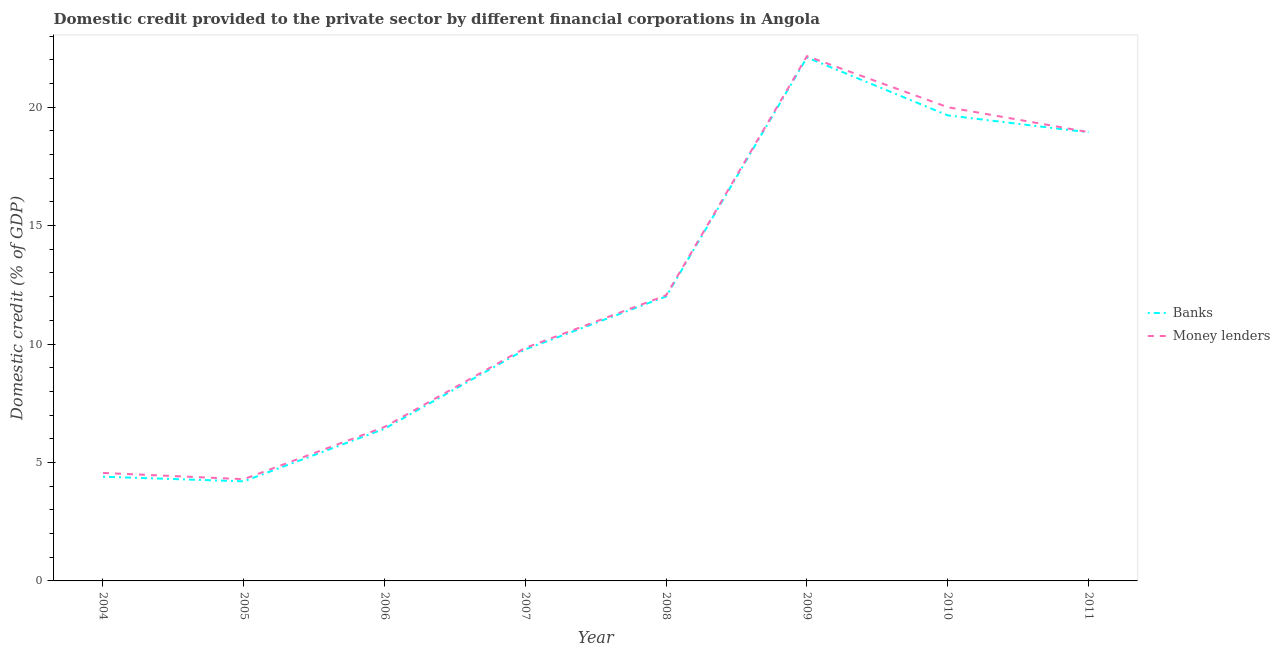Does the line corresponding to domestic credit provided by money lenders intersect with the line corresponding to domestic credit provided by banks?
Provide a short and direct response. No. Is the number of lines equal to the number of legend labels?
Offer a very short reply. Yes. What is the domestic credit provided by money lenders in 2006?
Offer a terse response. 6.5. Across all years, what is the maximum domestic credit provided by banks?
Your answer should be very brief. 22.1. Across all years, what is the minimum domestic credit provided by banks?
Offer a very short reply. 4.2. In which year was the domestic credit provided by banks minimum?
Your response must be concise. 2005. What is the total domestic credit provided by banks in the graph?
Your response must be concise. 97.5. What is the difference between the domestic credit provided by banks in 2006 and that in 2009?
Offer a terse response. -15.67. What is the difference between the domestic credit provided by money lenders in 2011 and the domestic credit provided by banks in 2006?
Ensure brevity in your answer.  12.52. What is the average domestic credit provided by banks per year?
Give a very brief answer. 12.19. In the year 2008, what is the difference between the domestic credit provided by money lenders and domestic credit provided by banks?
Keep it short and to the point. 0.05. In how many years, is the domestic credit provided by banks greater than 7 %?
Offer a very short reply. 5. What is the ratio of the domestic credit provided by banks in 2005 to that in 2008?
Ensure brevity in your answer.  0.35. What is the difference between the highest and the second highest domestic credit provided by money lenders?
Ensure brevity in your answer.  2.16. What is the difference between the highest and the lowest domestic credit provided by money lenders?
Your answer should be compact. 17.86. Is the domestic credit provided by money lenders strictly greater than the domestic credit provided by banks over the years?
Your answer should be very brief. Yes. What is the difference between two consecutive major ticks on the Y-axis?
Give a very brief answer. 5. How are the legend labels stacked?
Provide a succinct answer. Vertical. What is the title of the graph?
Your answer should be compact. Domestic credit provided to the private sector by different financial corporations in Angola. What is the label or title of the Y-axis?
Give a very brief answer. Domestic credit (% of GDP). What is the Domestic credit (% of GDP) of Banks in 2004?
Offer a terse response. 4.4. What is the Domestic credit (% of GDP) of Money lenders in 2004?
Ensure brevity in your answer.  4.56. What is the Domestic credit (% of GDP) of Banks in 2005?
Keep it short and to the point. 4.2. What is the Domestic credit (% of GDP) in Money lenders in 2005?
Provide a succinct answer. 4.29. What is the Domestic credit (% of GDP) in Banks in 2006?
Keep it short and to the point. 6.43. What is the Domestic credit (% of GDP) of Money lenders in 2006?
Your answer should be very brief. 6.5. What is the Domestic credit (% of GDP) in Banks in 2007?
Offer a terse response. 9.77. What is the Domestic credit (% of GDP) of Money lenders in 2007?
Your response must be concise. 9.84. What is the Domestic credit (% of GDP) in Banks in 2008?
Keep it short and to the point. 12.01. What is the Domestic credit (% of GDP) of Money lenders in 2008?
Offer a terse response. 12.06. What is the Domestic credit (% of GDP) in Banks in 2009?
Provide a short and direct response. 22.1. What is the Domestic credit (% of GDP) of Money lenders in 2009?
Keep it short and to the point. 22.15. What is the Domestic credit (% of GDP) of Banks in 2010?
Offer a terse response. 19.65. What is the Domestic credit (% of GDP) of Money lenders in 2010?
Keep it short and to the point. 20. What is the Domestic credit (% of GDP) in Banks in 2011?
Give a very brief answer. 18.94. What is the Domestic credit (% of GDP) in Money lenders in 2011?
Keep it short and to the point. 18.95. Across all years, what is the maximum Domestic credit (% of GDP) in Banks?
Keep it short and to the point. 22.1. Across all years, what is the maximum Domestic credit (% of GDP) in Money lenders?
Provide a short and direct response. 22.15. Across all years, what is the minimum Domestic credit (% of GDP) of Banks?
Keep it short and to the point. 4.2. Across all years, what is the minimum Domestic credit (% of GDP) of Money lenders?
Ensure brevity in your answer.  4.29. What is the total Domestic credit (% of GDP) in Banks in the graph?
Ensure brevity in your answer.  97.5. What is the total Domestic credit (% of GDP) of Money lenders in the graph?
Ensure brevity in your answer.  98.35. What is the difference between the Domestic credit (% of GDP) in Banks in 2004 and that in 2005?
Your response must be concise. 0.2. What is the difference between the Domestic credit (% of GDP) in Money lenders in 2004 and that in 2005?
Provide a short and direct response. 0.26. What is the difference between the Domestic credit (% of GDP) in Banks in 2004 and that in 2006?
Provide a succinct answer. -2.03. What is the difference between the Domestic credit (% of GDP) in Money lenders in 2004 and that in 2006?
Your response must be concise. -1.94. What is the difference between the Domestic credit (% of GDP) of Banks in 2004 and that in 2007?
Offer a terse response. -5.38. What is the difference between the Domestic credit (% of GDP) of Money lenders in 2004 and that in 2007?
Keep it short and to the point. -5.28. What is the difference between the Domestic credit (% of GDP) in Banks in 2004 and that in 2008?
Offer a very short reply. -7.61. What is the difference between the Domestic credit (% of GDP) of Money lenders in 2004 and that in 2008?
Offer a terse response. -7.5. What is the difference between the Domestic credit (% of GDP) in Banks in 2004 and that in 2009?
Provide a succinct answer. -17.7. What is the difference between the Domestic credit (% of GDP) of Money lenders in 2004 and that in 2009?
Make the answer very short. -17.6. What is the difference between the Domestic credit (% of GDP) in Banks in 2004 and that in 2010?
Your answer should be very brief. -15.25. What is the difference between the Domestic credit (% of GDP) in Money lenders in 2004 and that in 2010?
Your answer should be compact. -15.44. What is the difference between the Domestic credit (% of GDP) of Banks in 2004 and that in 2011?
Offer a terse response. -14.54. What is the difference between the Domestic credit (% of GDP) of Money lenders in 2004 and that in 2011?
Offer a very short reply. -14.39. What is the difference between the Domestic credit (% of GDP) of Banks in 2005 and that in 2006?
Give a very brief answer. -2.22. What is the difference between the Domestic credit (% of GDP) in Money lenders in 2005 and that in 2006?
Your answer should be very brief. -2.21. What is the difference between the Domestic credit (% of GDP) of Banks in 2005 and that in 2007?
Your response must be concise. -5.57. What is the difference between the Domestic credit (% of GDP) of Money lenders in 2005 and that in 2007?
Your response must be concise. -5.54. What is the difference between the Domestic credit (% of GDP) of Banks in 2005 and that in 2008?
Give a very brief answer. -7.81. What is the difference between the Domestic credit (% of GDP) of Money lenders in 2005 and that in 2008?
Make the answer very short. -7.76. What is the difference between the Domestic credit (% of GDP) of Banks in 2005 and that in 2009?
Keep it short and to the point. -17.9. What is the difference between the Domestic credit (% of GDP) of Money lenders in 2005 and that in 2009?
Make the answer very short. -17.86. What is the difference between the Domestic credit (% of GDP) of Banks in 2005 and that in 2010?
Your answer should be compact. -15.45. What is the difference between the Domestic credit (% of GDP) of Money lenders in 2005 and that in 2010?
Ensure brevity in your answer.  -15.7. What is the difference between the Domestic credit (% of GDP) in Banks in 2005 and that in 2011?
Your answer should be very brief. -14.73. What is the difference between the Domestic credit (% of GDP) in Money lenders in 2005 and that in 2011?
Make the answer very short. -14.65. What is the difference between the Domestic credit (% of GDP) of Banks in 2006 and that in 2007?
Your answer should be very brief. -3.35. What is the difference between the Domestic credit (% of GDP) of Money lenders in 2006 and that in 2007?
Provide a succinct answer. -3.34. What is the difference between the Domestic credit (% of GDP) of Banks in 2006 and that in 2008?
Keep it short and to the point. -5.58. What is the difference between the Domestic credit (% of GDP) of Money lenders in 2006 and that in 2008?
Keep it short and to the point. -5.56. What is the difference between the Domestic credit (% of GDP) in Banks in 2006 and that in 2009?
Your answer should be very brief. -15.67. What is the difference between the Domestic credit (% of GDP) of Money lenders in 2006 and that in 2009?
Ensure brevity in your answer.  -15.65. What is the difference between the Domestic credit (% of GDP) of Banks in 2006 and that in 2010?
Provide a succinct answer. -13.23. What is the difference between the Domestic credit (% of GDP) of Money lenders in 2006 and that in 2010?
Give a very brief answer. -13.5. What is the difference between the Domestic credit (% of GDP) in Banks in 2006 and that in 2011?
Make the answer very short. -12.51. What is the difference between the Domestic credit (% of GDP) in Money lenders in 2006 and that in 2011?
Keep it short and to the point. -12.44. What is the difference between the Domestic credit (% of GDP) of Banks in 2007 and that in 2008?
Offer a terse response. -2.24. What is the difference between the Domestic credit (% of GDP) of Money lenders in 2007 and that in 2008?
Provide a succinct answer. -2.22. What is the difference between the Domestic credit (% of GDP) of Banks in 2007 and that in 2009?
Offer a terse response. -12.32. What is the difference between the Domestic credit (% of GDP) of Money lenders in 2007 and that in 2009?
Offer a very short reply. -12.32. What is the difference between the Domestic credit (% of GDP) of Banks in 2007 and that in 2010?
Keep it short and to the point. -9.88. What is the difference between the Domestic credit (% of GDP) in Money lenders in 2007 and that in 2010?
Your answer should be very brief. -10.16. What is the difference between the Domestic credit (% of GDP) of Banks in 2007 and that in 2011?
Offer a very short reply. -9.16. What is the difference between the Domestic credit (% of GDP) of Money lenders in 2007 and that in 2011?
Offer a terse response. -9.11. What is the difference between the Domestic credit (% of GDP) of Banks in 2008 and that in 2009?
Your answer should be compact. -10.09. What is the difference between the Domestic credit (% of GDP) in Money lenders in 2008 and that in 2009?
Provide a short and direct response. -10.1. What is the difference between the Domestic credit (% of GDP) in Banks in 2008 and that in 2010?
Provide a succinct answer. -7.64. What is the difference between the Domestic credit (% of GDP) of Money lenders in 2008 and that in 2010?
Your answer should be very brief. -7.94. What is the difference between the Domestic credit (% of GDP) in Banks in 2008 and that in 2011?
Offer a very short reply. -6.93. What is the difference between the Domestic credit (% of GDP) of Money lenders in 2008 and that in 2011?
Provide a short and direct response. -6.89. What is the difference between the Domestic credit (% of GDP) in Banks in 2009 and that in 2010?
Make the answer very short. 2.45. What is the difference between the Domestic credit (% of GDP) in Money lenders in 2009 and that in 2010?
Keep it short and to the point. 2.16. What is the difference between the Domestic credit (% of GDP) in Banks in 2009 and that in 2011?
Provide a succinct answer. 3.16. What is the difference between the Domestic credit (% of GDP) in Money lenders in 2009 and that in 2011?
Your response must be concise. 3.21. What is the difference between the Domestic credit (% of GDP) of Banks in 2010 and that in 2011?
Offer a terse response. 0.72. What is the difference between the Domestic credit (% of GDP) in Money lenders in 2010 and that in 2011?
Make the answer very short. 1.05. What is the difference between the Domestic credit (% of GDP) of Banks in 2004 and the Domestic credit (% of GDP) of Money lenders in 2005?
Make the answer very short. 0.1. What is the difference between the Domestic credit (% of GDP) of Banks in 2004 and the Domestic credit (% of GDP) of Money lenders in 2006?
Offer a terse response. -2.1. What is the difference between the Domestic credit (% of GDP) in Banks in 2004 and the Domestic credit (% of GDP) in Money lenders in 2007?
Make the answer very short. -5.44. What is the difference between the Domestic credit (% of GDP) of Banks in 2004 and the Domestic credit (% of GDP) of Money lenders in 2008?
Provide a succinct answer. -7.66. What is the difference between the Domestic credit (% of GDP) in Banks in 2004 and the Domestic credit (% of GDP) in Money lenders in 2009?
Offer a terse response. -17.75. What is the difference between the Domestic credit (% of GDP) in Banks in 2004 and the Domestic credit (% of GDP) in Money lenders in 2010?
Make the answer very short. -15.6. What is the difference between the Domestic credit (% of GDP) of Banks in 2004 and the Domestic credit (% of GDP) of Money lenders in 2011?
Ensure brevity in your answer.  -14.55. What is the difference between the Domestic credit (% of GDP) in Banks in 2005 and the Domestic credit (% of GDP) in Money lenders in 2006?
Provide a succinct answer. -2.3. What is the difference between the Domestic credit (% of GDP) in Banks in 2005 and the Domestic credit (% of GDP) in Money lenders in 2007?
Ensure brevity in your answer.  -5.63. What is the difference between the Domestic credit (% of GDP) of Banks in 2005 and the Domestic credit (% of GDP) of Money lenders in 2008?
Offer a terse response. -7.85. What is the difference between the Domestic credit (% of GDP) of Banks in 2005 and the Domestic credit (% of GDP) of Money lenders in 2009?
Your answer should be very brief. -17.95. What is the difference between the Domestic credit (% of GDP) of Banks in 2005 and the Domestic credit (% of GDP) of Money lenders in 2010?
Your answer should be very brief. -15.79. What is the difference between the Domestic credit (% of GDP) of Banks in 2005 and the Domestic credit (% of GDP) of Money lenders in 2011?
Your answer should be very brief. -14.74. What is the difference between the Domestic credit (% of GDP) in Banks in 2006 and the Domestic credit (% of GDP) in Money lenders in 2007?
Provide a short and direct response. -3.41. What is the difference between the Domestic credit (% of GDP) in Banks in 2006 and the Domestic credit (% of GDP) in Money lenders in 2008?
Ensure brevity in your answer.  -5.63. What is the difference between the Domestic credit (% of GDP) in Banks in 2006 and the Domestic credit (% of GDP) in Money lenders in 2009?
Provide a succinct answer. -15.73. What is the difference between the Domestic credit (% of GDP) in Banks in 2006 and the Domestic credit (% of GDP) in Money lenders in 2010?
Give a very brief answer. -13.57. What is the difference between the Domestic credit (% of GDP) of Banks in 2006 and the Domestic credit (% of GDP) of Money lenders in 2011?
Provide a short and direct response. -12.52. What is the difference between the Domestic credit (% of GDP) of Banks in 2007 and the Domestic credit (% of GDP) of Money lenders in 2008?
Give a very brief answer. -2.28. What is the difference between the Domestic credit (% of GDP) in Banks in 2007 and the Domestic credit (% of GDP) in Money lenders in 2009?
Offer a terse response. -12.38. What is the difference between the Domestic credit (% of GDP) in Banks in 2007 and the Domestic credit (% of GDP) in Money lenders in 2010?
Your response must be concise. -10.22. What is the difference between the Domestic credit (% of GDP) in Banks in 2007 and the Domestic credit (% of GDP) in Money lenders in 2011?
Your answer should be very brief. -9.17. What is the difference between the Domestic credit (% of GDP) in Banks in 2008 and the Domestic credit (% of GDP) in Money lenders in 2009?
Your answer should be very brief. -10.14. What is the difference between the Domestic credit (% of GDP) in Banks in 2008 and the Domestic credit (% of GDP) in Money lenders in 2010?
Offer a very short reply. -7.99. What is the difference between the Domestic credit (% of GDP) in Banks in 2008 and the Domestic credit (% of GDP) in Money lenders in 2011?
Your answer should be very brief. -6.94. What is the difference between the Domestic credit (% of GDP) of Banks in 2009 and the Domestic credit (% of GDP) of Money lenders in 2010?
Provide a succinct answer. 2.1. What is the difference between the Domestic credit (% of GDP) of Banks in 2009 and the Domestic credit (% of GDP) of Money lenders in 2011?
Keep it short and to the point. 3.15. What is the difference between the Domestic credit (% of GDP) in Banks in 2010 and the Domestic credit (% of GDP) in Money lenders in 2011?
Offer a very short reply. 0.71. What is the average Domestic credit (% of GDP) of Banks per year?
Keep it short and to the point. 12.19. What is the average Domestic credit (% of GDP) in Money lenders per year?
Offer a very short reply. 12.29. In the year 2004, what is the difference between the Domestic credit (% of GDP) in Banks and Domestic credit (% of GDP) in Money lenders?
Keep it short and to the point. -0.16. In the year 2005, what is the difference between the Domestic credit (% of GDP) of Banks and Domestic credit (% of GDP) of Money lenders?
Offer a terse response. -0.09. In the year 2006, what is the difference between the Domestic credit (% of GDP) of Banks and Domestic credit (% of GDP) of Money lenders?
Provide a succinct answer. -0.08. In the year 2007, what is the difference between the Domestic credit (% of GDP) in Banks and Domestic credit (% of GDP) in Money lenders?
Provide a succinct answer. -0.06. In the year 2008, what is the difference between the Domestic credit (% of GDP) in Banks and Domestic credit (% of GDP) in Money lenders?
Keep it short and to the point. -0.05. In the year 2009, what is the difference between the Domestic credit (% of GDP) of Banks and Domestic credit (% of GDP) of Money lenders?
Ensure brevity in your answer.  -0.05. In the year 2010, what is the difference between the Domestic credit (% of GDP) in Banks and Domestic credit (% of GDP) in Money lenders?
Provide a succinct answer. -0.34. In the year 2011, what is the difference between the Domestic credit (% of GDP) of Banks and Domestic credit (% of GDP) of Money lenders?
Provide a short and direct response. -0.01. What is the ratio of the Domestic credit (% of GDP) of Banks in 2004 to that in 2005?
Provide a short and direct response. 1.05. What is the ratio of the Domestic credit (% of GDP) in Money lenders in 2004 to that in 2005?
Provide a succinct answer. 1.06. What is the ratio of the Domestic credit (% of GDP) in Banks in 2004 to that in 2006?
Provide a succinct answer. 0.68. What is the ratio of the Domestic credit (% of GDP) in Money lenders in 2004 to that in 2006?
Give a very brief answer. 0.7. What is the ratio of the Domestic credit (% of GDP) of Banks in 2004 to that in 2007?
Your answer should be very brief. 0.45. What is the ratio of the Domestic credit (% of GDP) in Money lenders in 2004 to that in 2007?
Ensure brevity in your answer.  0.46. What is the ratio of the Domestic credit (% of GDP) in Banks in 2004 to that in 2008?
Give a very brief answer. 0.37. What is the ratio of the Domestic credit (% of GDP) of Money lenders in 2004 to that in 2008?
Provide a succinct answer. 0.38. What is the ratio of the Domestic credit (% of GDP) of Banks in 2004 to that in 2009?
Make the answer very short. 0.2. What is the ratio of the Domestic credit (% of GDP) in Money lenders in 2004 to that in 2009?
Provide a short and direct response. 0.21. What is the ratio of the Domestic credit (% of GDP) in Banks in 2004 to that in 2010?
Ensure brevity in your answer.  0.22. What is the ratio of the Domestic credit (% of GDP) in Money lenders in 2004 to that in 2010?
Keep it short and to the point. 0.23. What is the ratio of the Domestic credit (% of GDP) in Banks in 2004 to that in 2011?
Your response must be concise. 0.23. What is the ratio of the Domestic credit (% of GDP) of Money lenders in 2004 to that in 2011?
Provide a succinct answer. 0.24. What is the ratio of the Domestic credit (% of GDP) of Banks in 2005 to that in 2006?
Your response must be concise. 0.65. What is the ratio of the Domestic credit (% of GDP) in Money lenders in 2005 to that in 2006?
Provide a succinct answer. 0.66. What is the ratio of the Domestic credit (% of GDP) in Banks in 2005 to that in 2007?
Your answer should be compact. 0.43. What is the ratio of the Domestic credit (% of GDP) of Money lenders in 2005 to that in 2007?
Offer a very short reply. 0.44. What is the ratio of the Domestic credit (% of GDP) of Money lenders in 2005 to that in 2008?
Provide a short and direct response. 0.36. What is the ratio of the Domestic credit (% of GDP) in Banks in 2005 to that in 2009?
Provide a succinct answer. 0.19. What is the ratio of the Domestic credit (% of GDP) of Money lenders in 2005 to that in 2009?
Make the answer very short. 0.19. What is the ratio of the Domestic credit (% of GDP) of Banks in 2005 to that in 2010?
Ensure brevity in your answer.  0.21. What is the ratio of the Domestic credit (% of GDP) in Money lenders in 2005 to that in 2010?
Give a very brief answer. 0.21. What is the ratio of the Domestic credit (% of GDP) of Banks in 2005 to that in 2011?
Your answer should be very brief. 0.22. What is the ratio of the Domestic credit (% of GDP) in Money lenders in 2005 to that in 2011?
Offer a terse response. 0.23. What is the ratio of the Domestic credit (% of GDP) of Banks in 2006 to that in 2007?
Make the answer very short. 0.66. What is the ratio of the Domestic credit (% of GDP) of Money lenders in 2006 to that in 2007?
Provide a succinct answer. 0.66. What is the ratio of the Domestic credit (% of GDP) of Banks in 2006 to that in 2008?
Your answer should be compact. 0.54. What is the ratio of the Domestic credit (% of GDP) in Money lenders in 2006 to that in 2008?
Ensure brevity in your answer.  0.54. What is the ratio of the Domestic credit (% of GDP) of Banks in 2006 to that in 2009?
Provide a succinct answer. 0.29. What is the ratio of the Domestic credit (% of GDP) of Money lenders in 2006 to that in 2009?
Provide a succinct answer. 0.29. What is the ratio of the Domestic credit (% of GDP) in Banks in 2006 to that in 2010?
Provide a succinct answer. 0.33. What is the ratio of the Domestic credit (% of GDP) of Money lenders in 2006 to that in 2010?
Ensure brevity in your answer.  0.33. What is the ratio of the Domestic credit (% of GDP) of Banks in 2006 to that in 2011?
Your answer should be very brief. 0.34. What is the ratio of the Domestic credit (% of GDP) in Money lenders in 2006 to that in 2011?
Provide a short and direct response. 0.34. What is the ratio of the Domestic credit (% of GDP) of Banks in 2007 to that in 2008?
Provide a short and direct response. 0.81. What is the ratio of the Domestic credit (% of GDP) of Money lenders in 2007 to that in 2008?
Give a very brief answer. 0.82. What is the ratio of the Domestic credit (% of GDP) in Banks in 2007 to that in 2009?
Offer a terse response. 0.44. What is the ratio of the Domestic credit (% of GDP) in Money lenders in 2007 to that in 2009?
Ensure brevity in your answer.  0.44. What is the ratio of the Domestic credit (% of GDP) of Banks in 2007 to that in 2010?
Your answer should be compact. 0.5. What is the ratio of the Domestic credit (% of GDP) in Money lenders in 2007 to that in 2010?
Make the answer very short. 0.49. What is the ratio of the Domestic credit (% of GDP) of Banks in 2007 to that in 2011?
Your response must be concise. 0.52. What is the ratio of the Domestic credit (% of GDP) of Money lenders in 2007 to that in 2011?
Your answer should be compact. 0.52. What is the ratio of the Domestic credit (% of GDP) in Banks in 2008 to that in 2009?
Your answer should be very brief. 0.54. What is the ratio of the Domestic credit (% of GDP) of Money lenders in 2008 to that in 2009?
Keep it short and to the point. 0.54. What is the ratio of the Domestic credit (% of GDP) in Banks in 2008 to that in 2010?
Make the answer very short. 0.61. What is the ratio of the Domestic credit (% of GDP) of Money lenders in 2008 to that in 2010?
Your answer should be compact. 0.6. What is the ratio of the Domestic credit (% of GDP) in Banks in 2008 to that in 2011?
Offer a very short reply. 0.63. What is the ratio of the Domestic credit (% of GDP) of Money lenders in 2008 to that in 2011?
Provide a succinct answer. 0.64. What is the ratio of the Domestic credit (% of GDP) in Banks in 2009 to that in 2010?
Your answer should be very brief. 1.12. What is the ratio of the Domestic credit (% of GDP) of Money lenders in 2009 to that in 2010?
Your answer should be very brief. 1.11. What is the ratio of the Domestic credit (% of GDP) of Banks in 2009 to that in 2011?
Your answer should be compact. 1.17. What is the ratio of the Domestic credit (% of GDP) of Money lenders in 2009 to that in 2011?
Provide a short and direct response. 1.17. What is the ratio of the Domestic credit (% of GDP) of Banks in 2010 to that in 2011?
Provide a succinct answer. 1.04. What is the ratio of the Domestic credit (% of GDP) in Money lenders in 2010 to that in 2011?
Give a very brief answer. 1.06. What is the difference between the highest and the second highest Domestic credit (% of GDP) in Banks?
Your response must be concise. 2.45. What is the difference between the highest and the second highest Domestic credit (% of GDP) of Money lenders?
Your response must be concise. 2.16. What is the difference between the highest and the lowest Domestic credit (% of GDP) in Banks?
Keep it short and to the point. 17.9. What is the difference between the highest and the lowest Domestic credit (% of GDP) of Money lenders?
Ensure brevity in your answer.  17.86. 